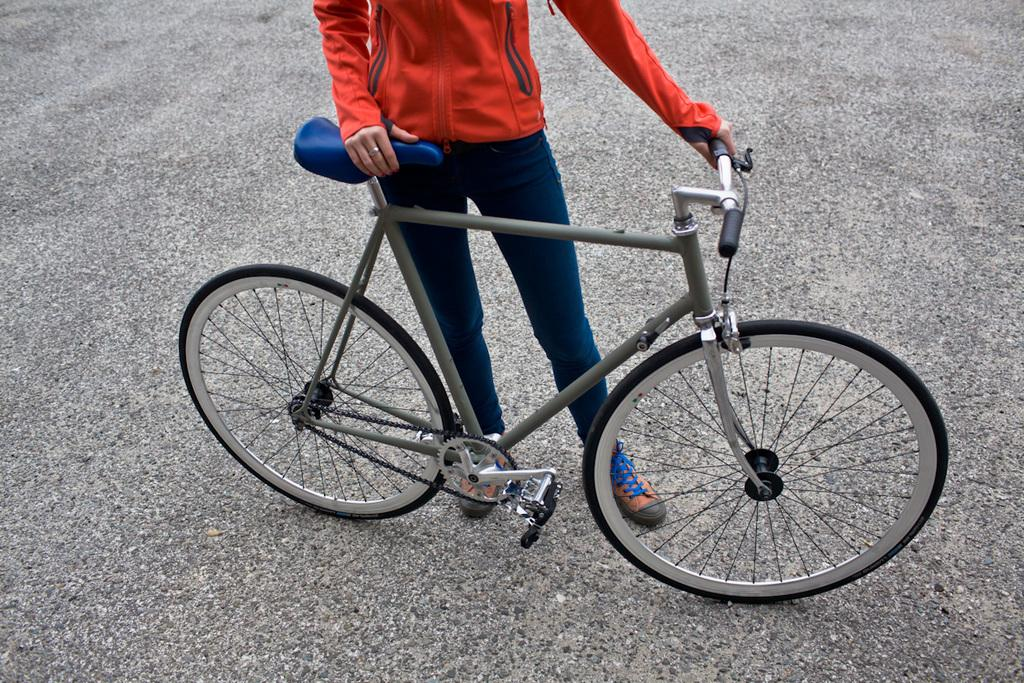What can be seen in the image that people use for transportation? There is a cycle on the path in the image. Who is holding the cycle in the image? A person is holding the cycle in the image. What is the person wearing on their upper body? The person is wearing an orange top. What is the person wearing on their lower body? The person is wearing blue pants. What type of test is being conducted on the person's nose in the image? There is no test being conducted on the person's nose in the image. 